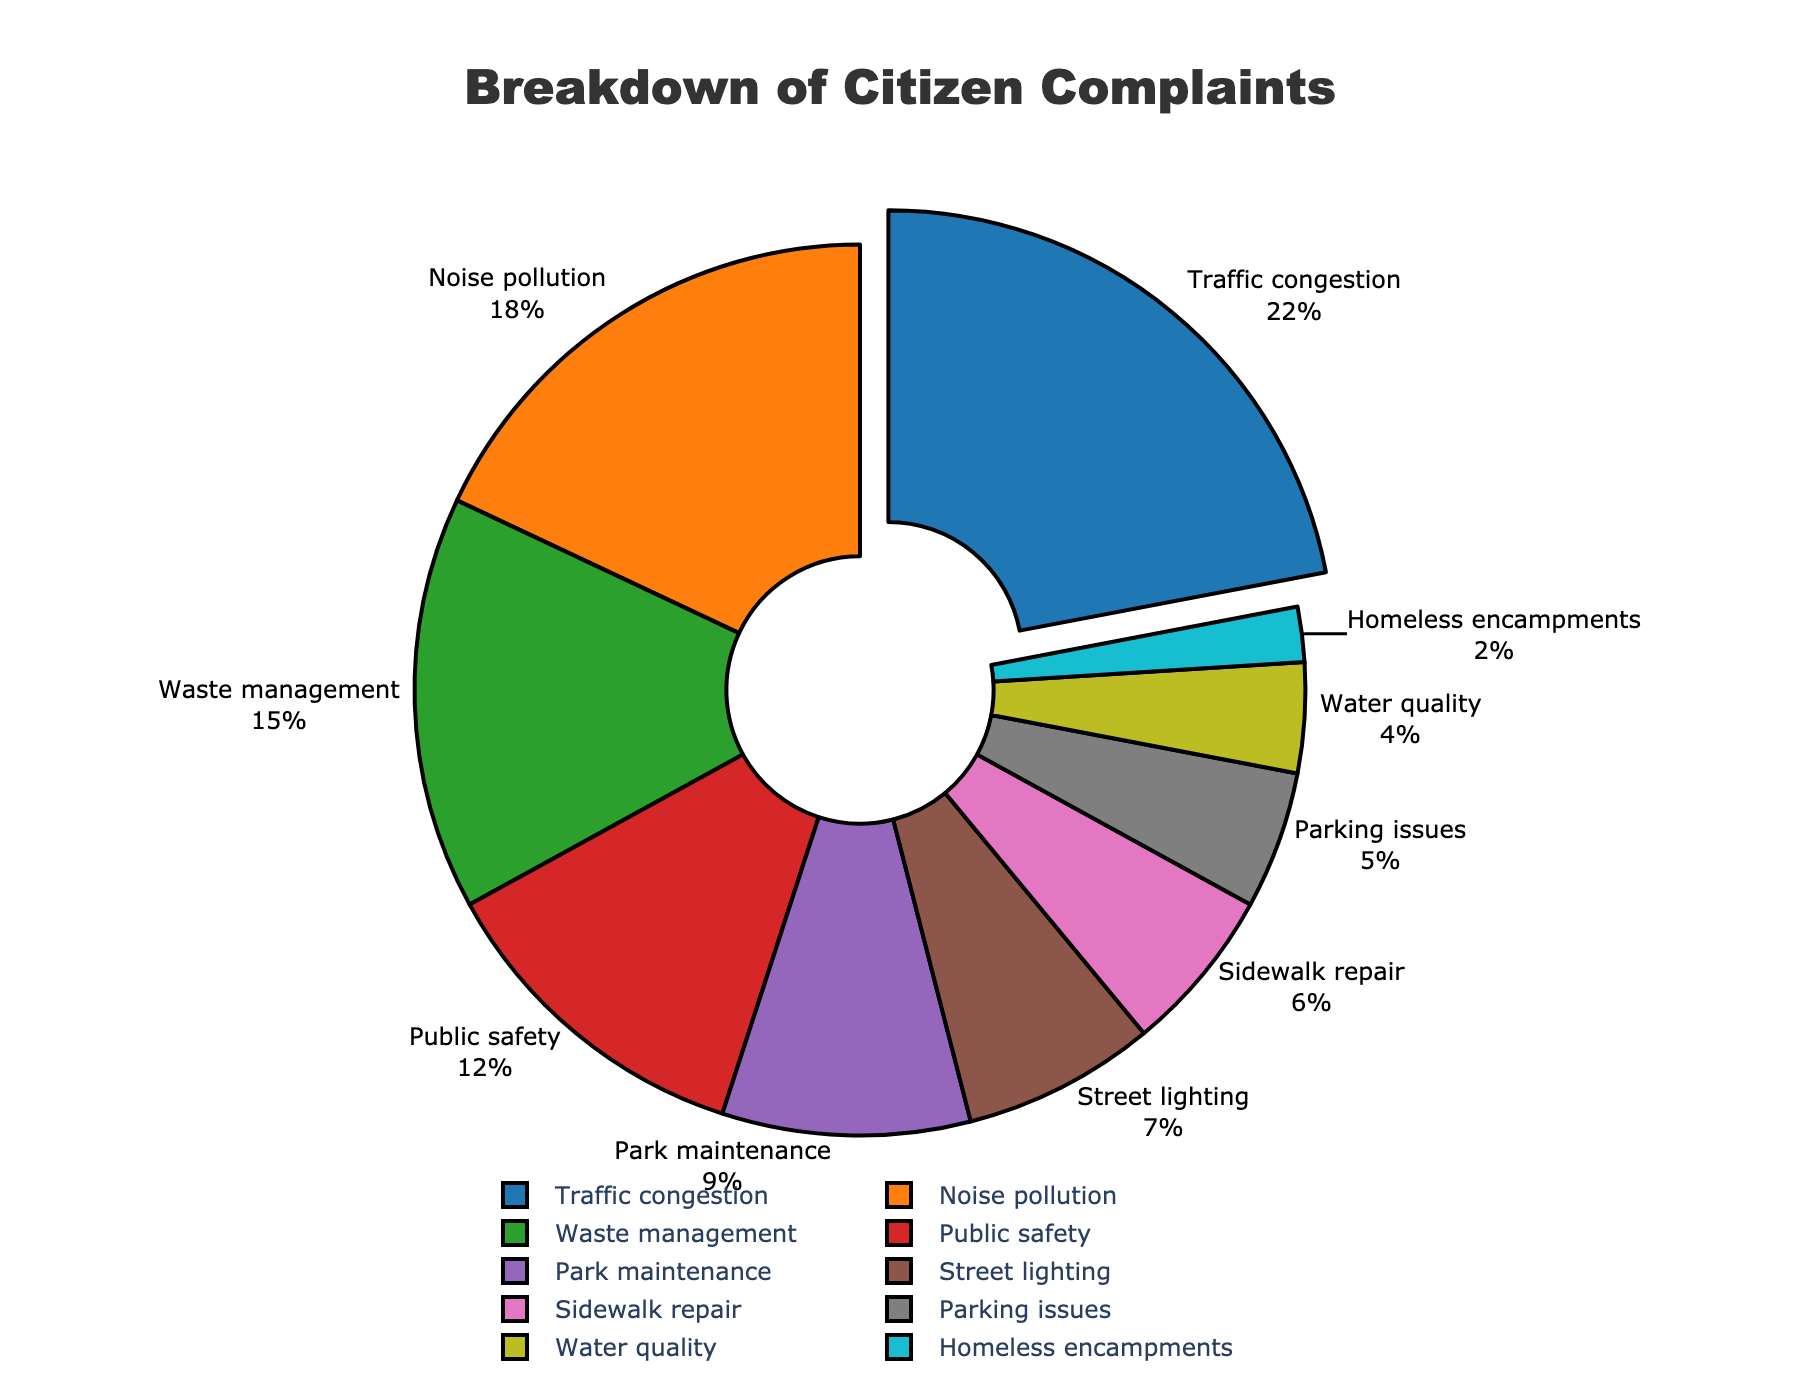Which category of complaints has the highest percentage? The category with the highest percentage is "Traffic congestion" with 22%. This can be identified by the visual pull-out of the slice in the pie chart, indicating it is the largest segment.
Answer: Traffic congestion What is the combined percentage of complaints related to Noise pollution and Waste management? Noise pollution has 18% and Waste management has 15%. Adding these together gives 18 + 15 = 33%.
Answer: 33% Is the percentage of Traffic congestion complaints greater than the combined percentage of Public safety and Park maintenance complaints? Traffic congestion is 22%. Public safety is 12% and Park maintenance is 9%. The combined percentage is 12 + 9 = 21%, which is less than 22%.
Answer: Yes Which category has the smallest proportion of complaints? The smallest proportion of complaints is for "Homeless encampments" with 2%, as indicated by the smallest slice in the pie chart.
Answer: Homeless encampments How does the percentage of Street lighting complaints compare to that of Sidewalk repair complaints? Street lighting has 7% while Sidewalk repair has 6%. Therefore, Street lighting complaints are 1% higher than Sidewalk repair complaints.
Answer: Street lighting is 1% higher Are there more complaints about Waste management or Parking issues, and by how much? Waste management has 15% while Parking issues have 5%. The difference is 15 - 5 = 10%. There are 10% more complaints about Waste management than Parking issues.
Answer: Waste management, 10% more What is the sum of the percentages of Traffic congestion, Noise pollution, and Waste management complaints? Traffic congestion is 22%, Noise pollution is 18%, and Waste management is 15%. The sum is 22 + 18 + 15 = 55%.
Answer: 55% If the categories Public safety, Park maintenance, and Street lighting are combined, do they account for more or less than 30% of total complaints? Public safety is 12%, Park maintenance is 9%, and Street lighting is 7%. The combined percentage is 12 + 9 + 7 = 28%, which is less than 30%.
Answer: Less than 30% Which category has a closer percentage to Water quality: Parking issues or Homeless encampments? Water quality has 4%, Parking issues have 5%, and Homeless encampments have 2%. The difference from Water quality is 5 - 4 = 1% for Parking issues and 4 - 2 = 2% for Homeless encampments. Thus, Parking issues are closer.
Answer: Parking issues 